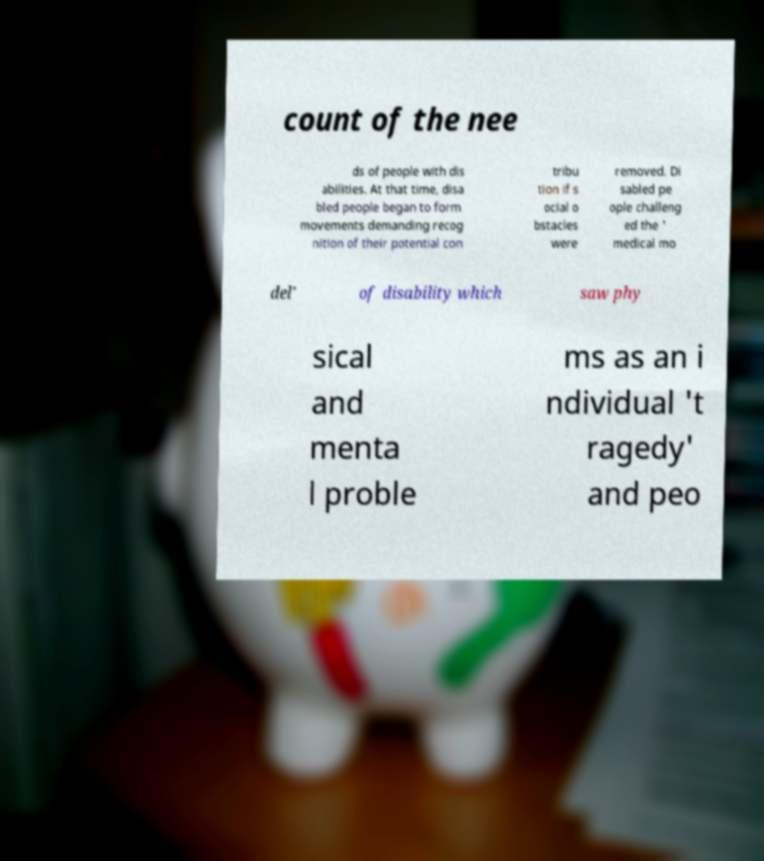Could you extract and type out the text from this image? count of the nee ds of people with dis abilities. At that time, disa bled people began to form movements demanding recog nition of their potential con tribu tion if s ocial o bstacles were removed. Di sabled pe ople challeng ed the ' medical mo del' of disability which saw phy sical and menta l proble ms as an i ndividual 't ragedy' and peo 